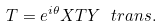<formula> <loc_0><loc_0><loc_500><loc_500>T = e ^ { i \theta } X T Y \ t r a n s .</formula> 